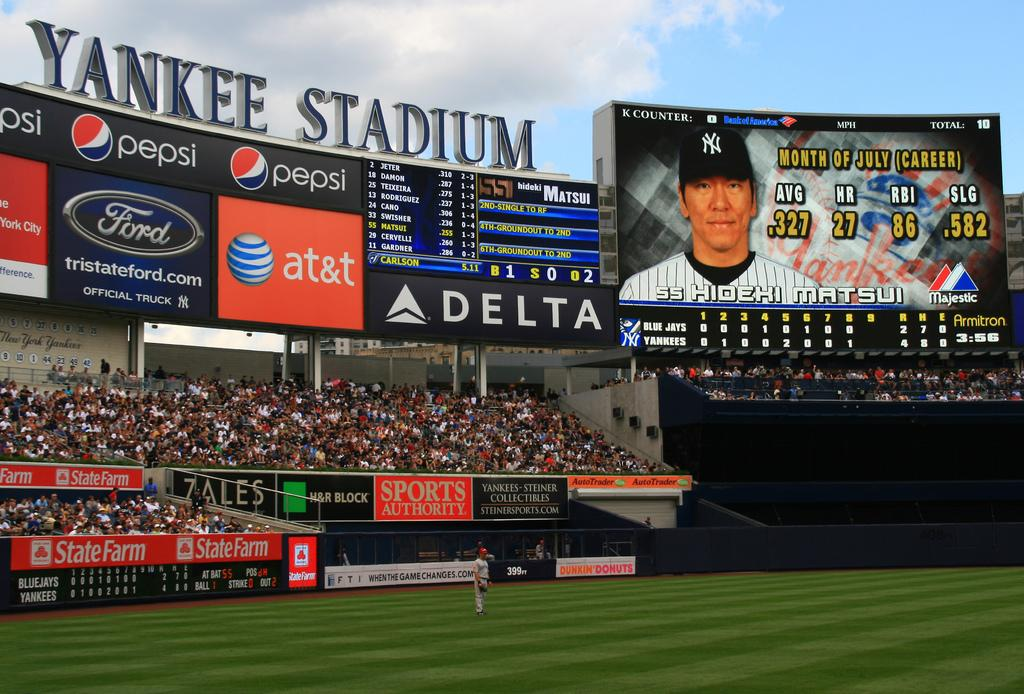<image>
Summarize the visual content of the image. Hidehi Matsui is up to bat during the Yankees game in New York City. 